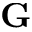Convert formula to latex. <formula><loc_0><loc_0><loc_500><loc_500>G</formula> 